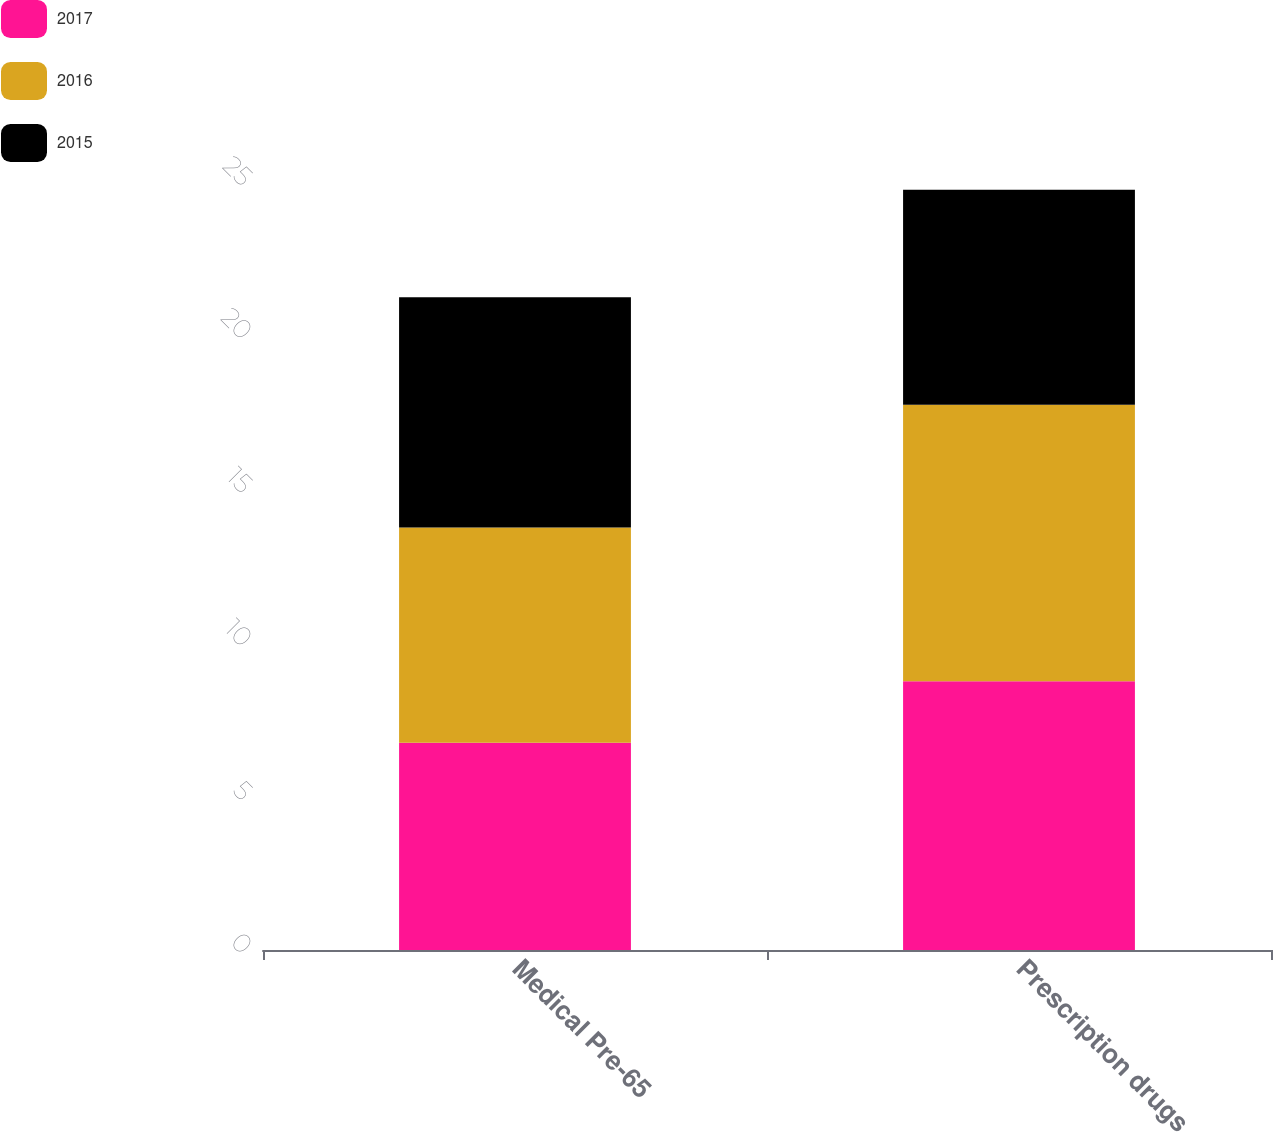<chart> <loc_0><loc_0><loc_500><loc_500><stacked_bar_chart><ecel><fcel>Medical Pre-65<fcel>Prescription drugs<nl><fcel>2017<fcel>6.75<fcel>8.75<nl><fcel>2016<fcel>7<fcel>9<nl><fcel>2015<fcel>7.5<fcel>7<nl></chart> 